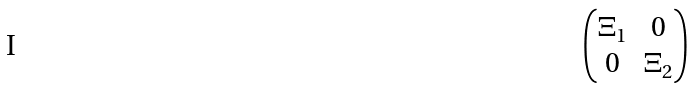<formula> <loc_0><loc_0><loc_500><loc_500>\begin{pmatrix} \Xi _ { 1 } & 0 \\ 0 & \Xi _ { 2 } \end{pmatrix}</formula> 